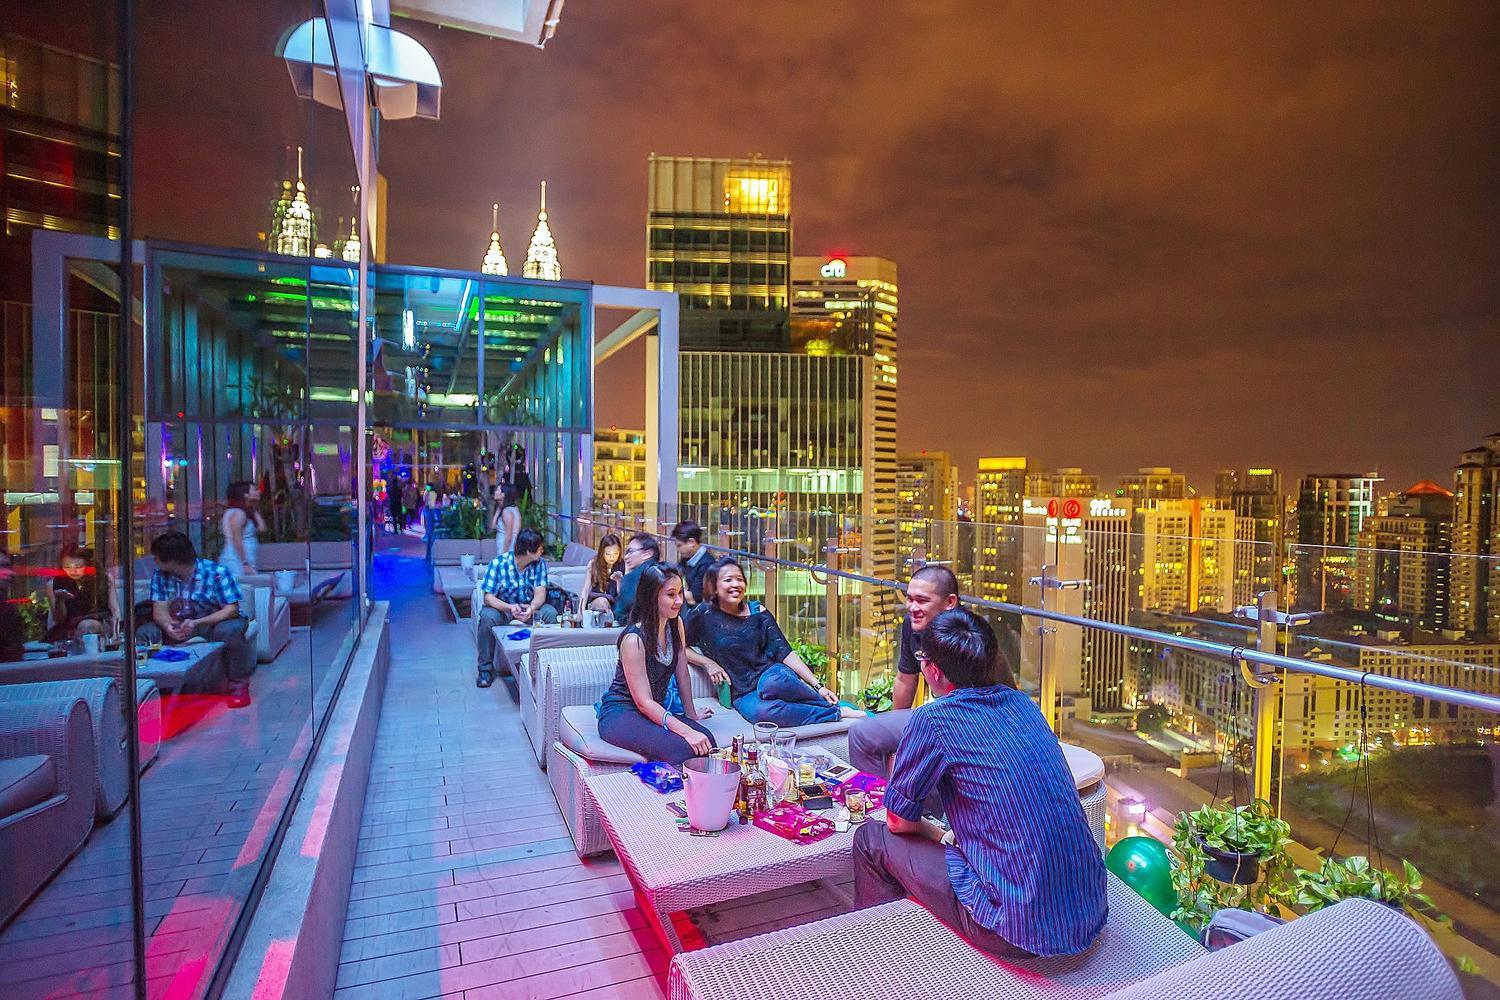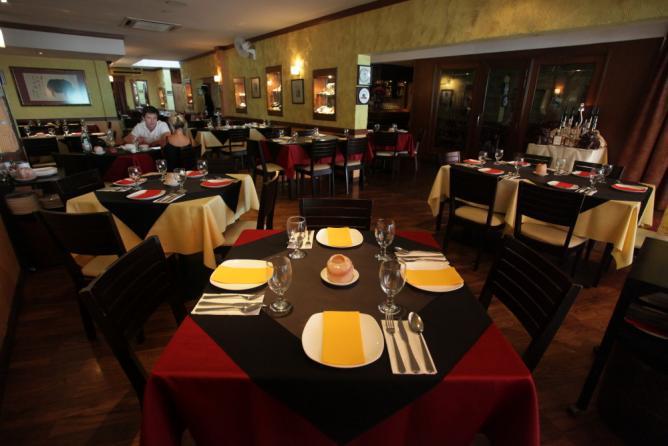The first image is the image on the left, the second image is the image on the right. Analyze the images presented: Is the assertion "At least one photo shows a dining area that is completely lit and also void of guests." valid? Answer yes or no. No. The first image is the image on the left, the second image is the image on the right. Examine the images to the left and right. Is the description "There are at least four round tables with four armless chairs." accurate? Answer yes or no. No. 